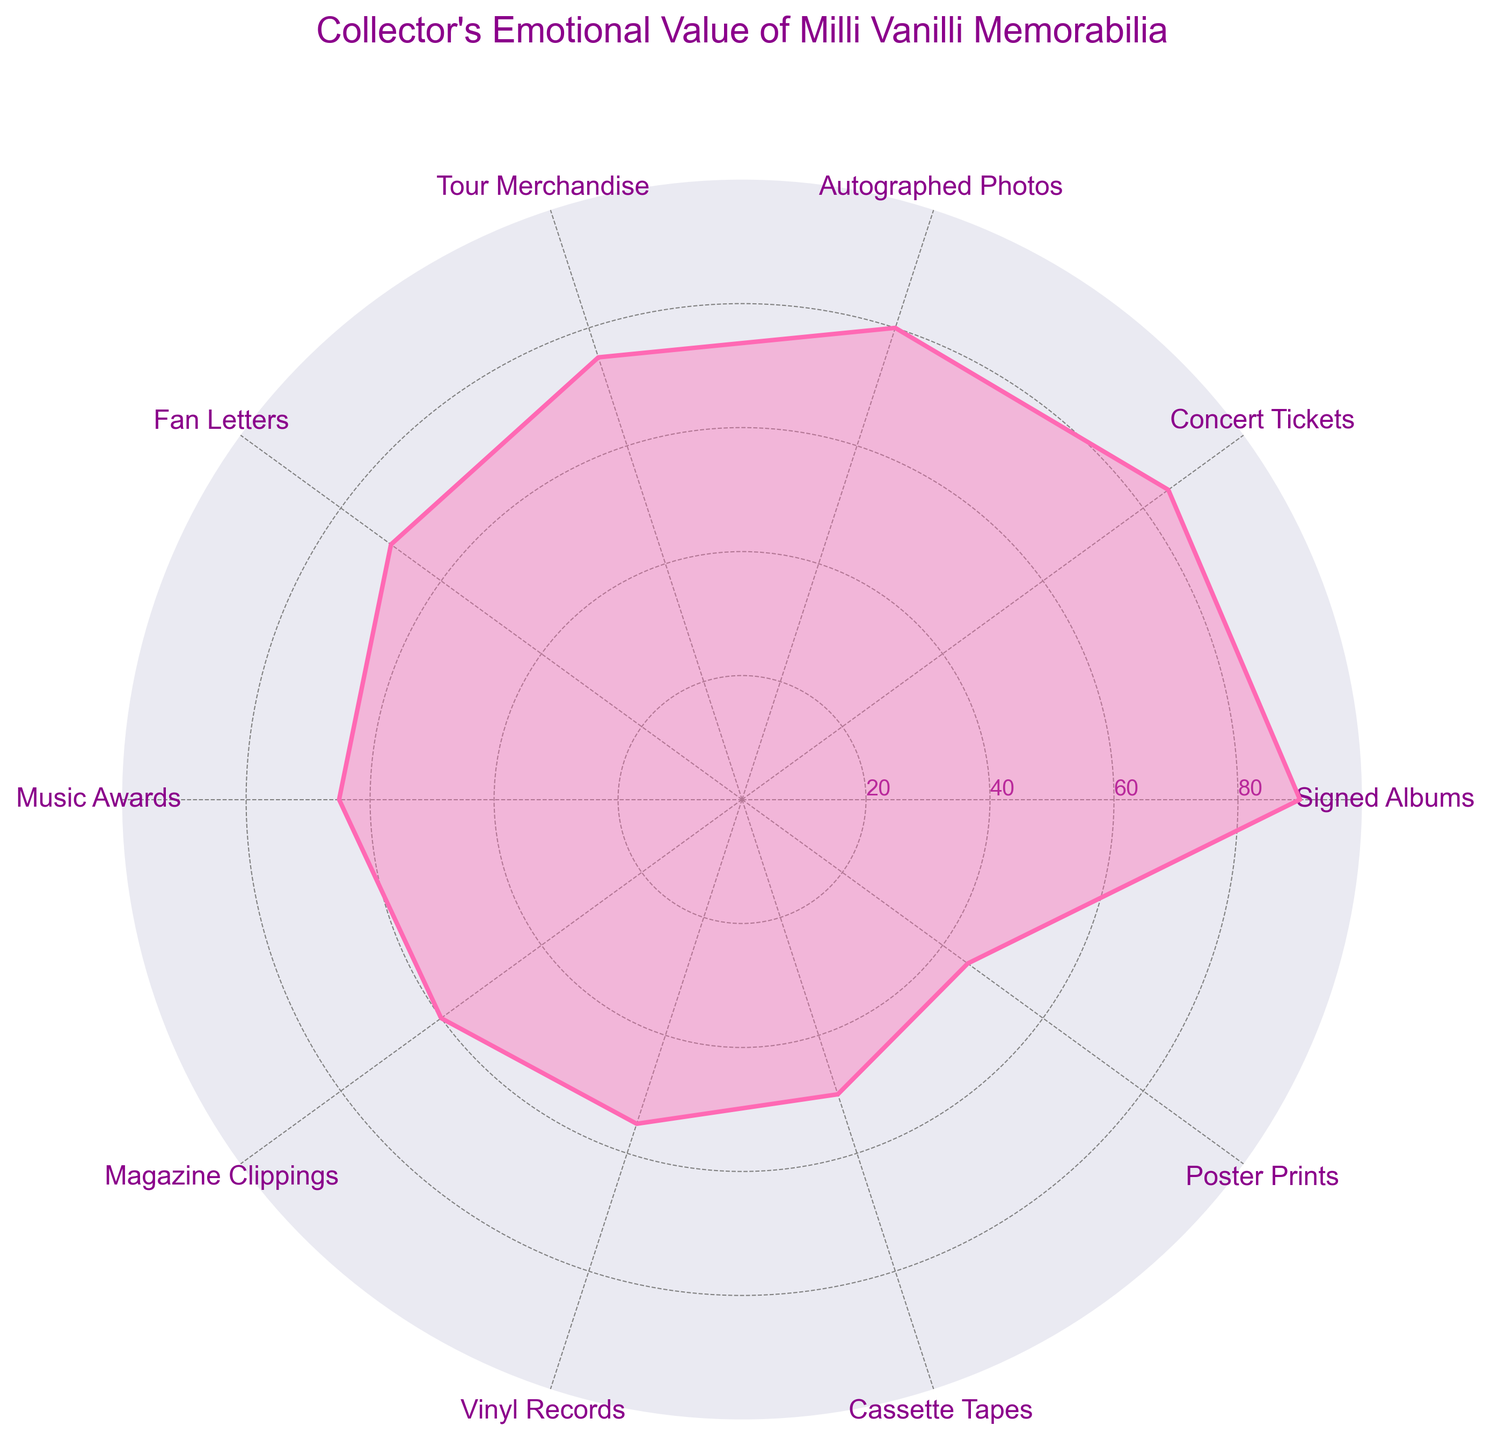What's the title of the figure? The title is placed prominently at the top of the chart, written in a larger font, and colored dark magenta.
Answer: Collector's Emotional Value of Milli Vanilli Memorabilia What category has the highest emotional value? The plot shows each category's value with a polygon, and the highest point on the graph indicates the highest value. This is Signed Albums at 90, highest on the plot.
Answer: Signed Albums Which category has the lowest emotional value? By looking at the plot, find the lowest point. Poster Prints have the lowest value on the plot, at 45.
Answer: Poster Prints How many categories are there in the plot? The plot has one axis per variable, and if we count the labels, there are 10 categories plotted around the circular axis.
Answer: 10 What is the emotional value of Tour Merchandise? Find the label Tour Merchandise on the plot and follow its value along the radial axis. The value is 75.
Answer: 75 What's the average emotional value of all categories? Sum all the values (90 + 85 + 80 + 75 + 70 + 65 + 60 + 55 + 50 + 45 = 675) and divide by the number of categories (10).
Answer: 67.5 Which category has a higher emotional value: Concert Tickets or Fan Letters? Find both categories on the plot and compare their values. Concert Tickets have an emotional value of 85, whereas Fan Letters have 70.
Answer: Concert Tickets What is the emotional value range in this plot? The range is the difference between the highest and lowest values. The highest is 90 (Signed Albums), and the lowest is 45 (Poster Prints), so the range is 90 - 45.
Answer: 45 Which categories have emotional values greater than 70? Identify categories above the 70 line on the plot. They are Signed Albums (90), Concert Tickets (85), Autographed Photos (80), and Tour Merchandise (75).
Answer: Signed Albums, Concert Tickets, Autographed Photos, Tour Merchandise 